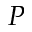Convert formula to latex. <formula><loc_0><loc_0><loc_500><loc_500>P</formula> 